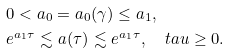<formula> <loc_0><loc_0><loc_500><loc_500>0 < a _ { 0 } & = a _ { 0 } ( \gamma ) \leq a _ { 1 } , \\ e ^ { a _ { 1 } \tau } \lesssim & \ a ( \tau ) \lesssim e ^ { a _ { 1 } \tau } , \quad t a u \geq 0 .</formula> 